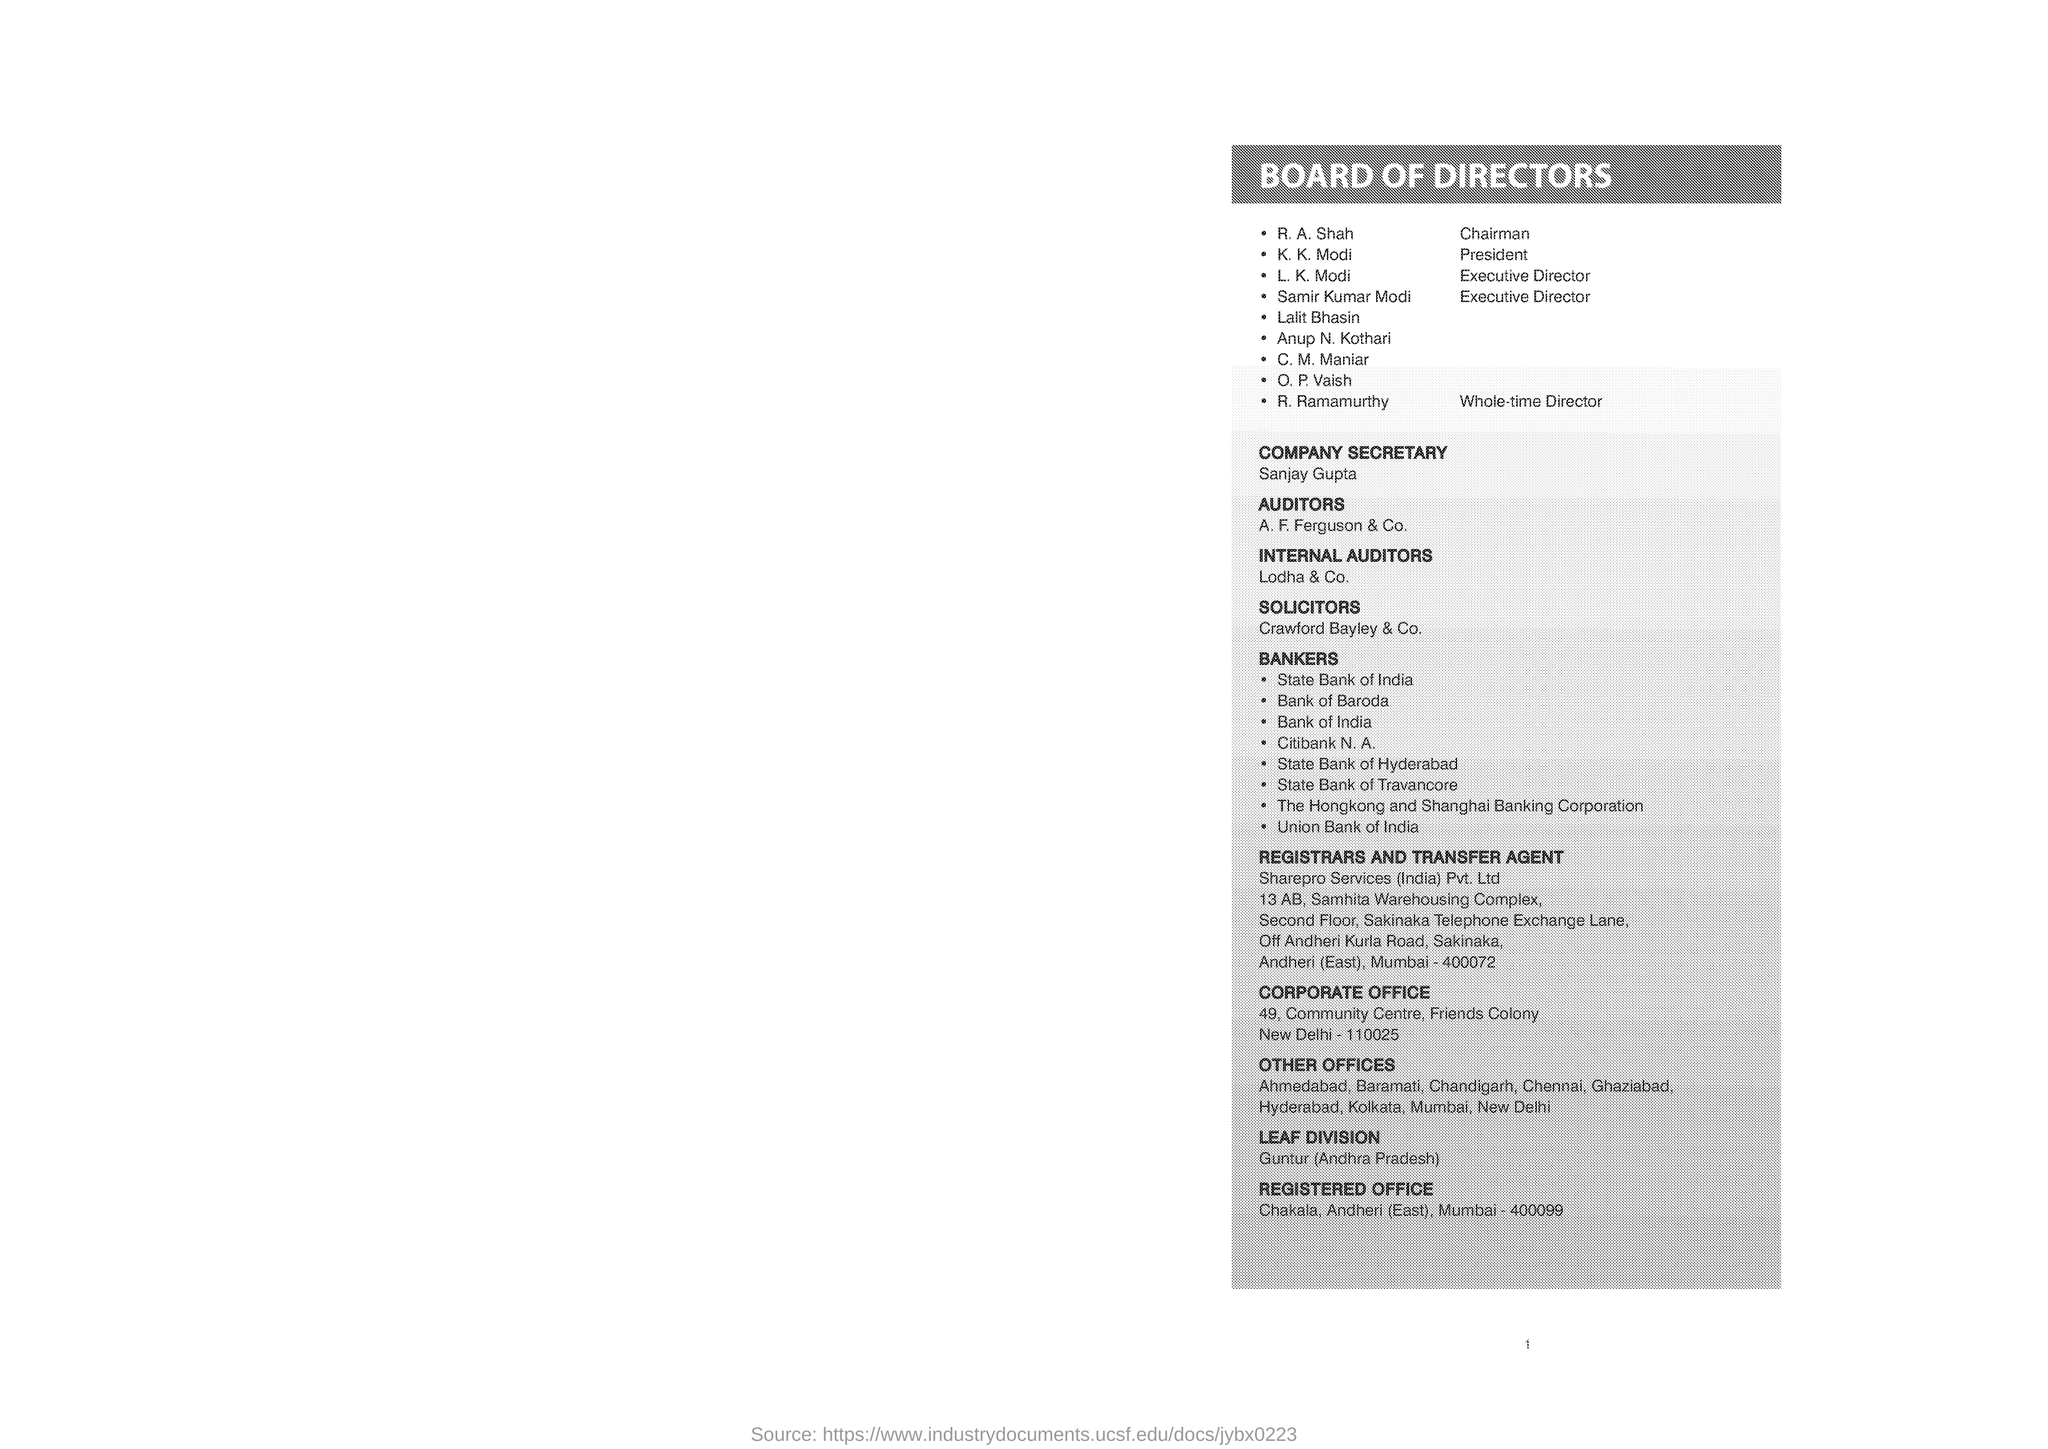List a handful of essential elements in this visual. R. Ramamurthy is the whole-time director. The registrar and transfer agent is Sharepro Services (India) Pvt. Ltd.. The first name on the list of the board of directors is R. A. Shah. The corporate office is located in New Delhi. The registered office is located in Mumbai. 